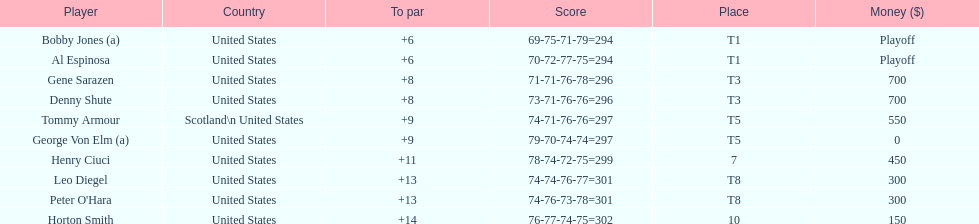How many players represented scotland? 1. 